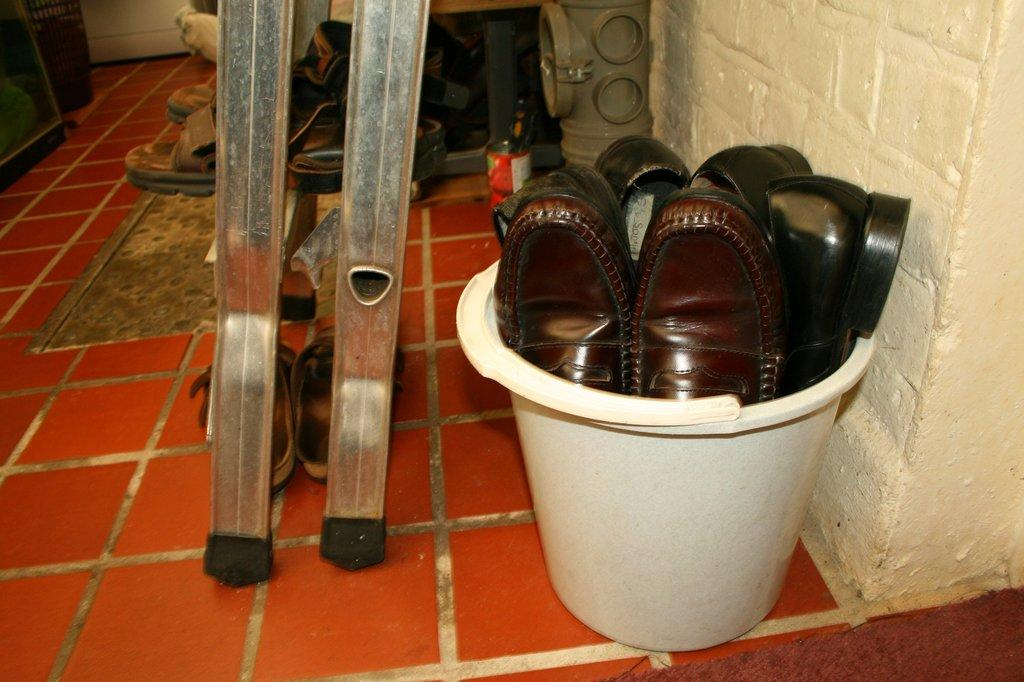What type of footwear is placed in a bucket in the image? There are shoes in a bucket in the image. What type of footwear is placed on metal rods in the image? There are sandals on metal rods in the image. What type of rock can be seen in the image? There is no rock present in the image. What view can be seen from the image? The image does not show a view; it shows shoes in a bucket and sandals on metal rods. What role does the dad play in the image? There is no reference to a dad or any person in the image. 